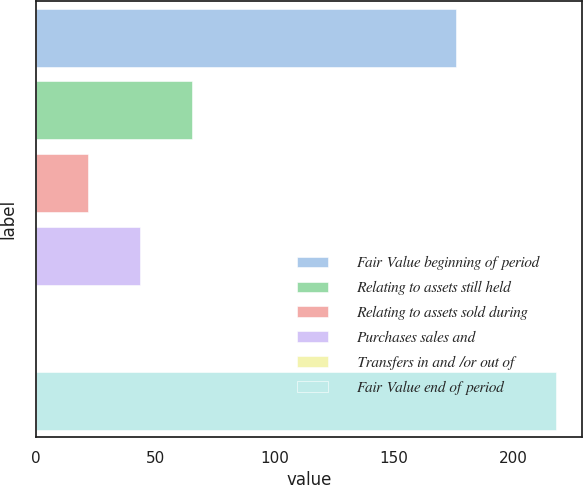Convert chart to OTSL. <chart><loc_0><loc_0><loc_500><loc_500><bar_chart><fcel>Fair Value beginning of period<fcel>Relating to assets still held<fcel>Relating to assets sold during<fcel>Purchases sales and<fcel>Transfers in and /or out of<fcel>Fair Value end of period<nl><fcel>176<fcel>65.47<fcel>21.89<fcel>43.68<fcel>0.1<fcel>218<nl></chart> 